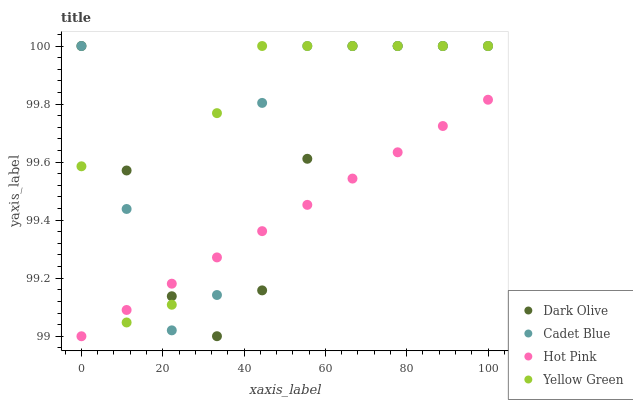Does Hot Pink have the minimum area under the curve?
Answer yes or no. Yes. Does Yellow Green have the maximum area under the curve?
Answer yes or no. Yes. Does Dark Olive have the minimum area under the curve?
Answer yes or no. No. Does Dark Olive have the maximum area under the curve?
Answer yes or no. No. Is Hot Pink the smoothest?
Answer yes or no. Yes. Is Cadet Blue the roughest?
Answer yes or no. Yes. Is Dark Olive the smoothest?
Answer yes or no. No. Is Dark Olive the roughest?
Answer yes or no. No. Does Hot Pink have the lowest value?
Answer yes or no. Yes. Does Dark Olive have the lowest value?
Answer yes or no. No. Does Yellow Green have the highest value?
Answer yes or no. Yes. Does Hot Pink have the highest value?
Answer yes or no. No. Does Hot Pink intersect Yellow Green?
Answer yes or no. Yes. Is Hot Pink less than Yellow Green?
Answer yes or no. No. Is Hot Pink greater than Yellow Green?
Answer yes or no. No. 